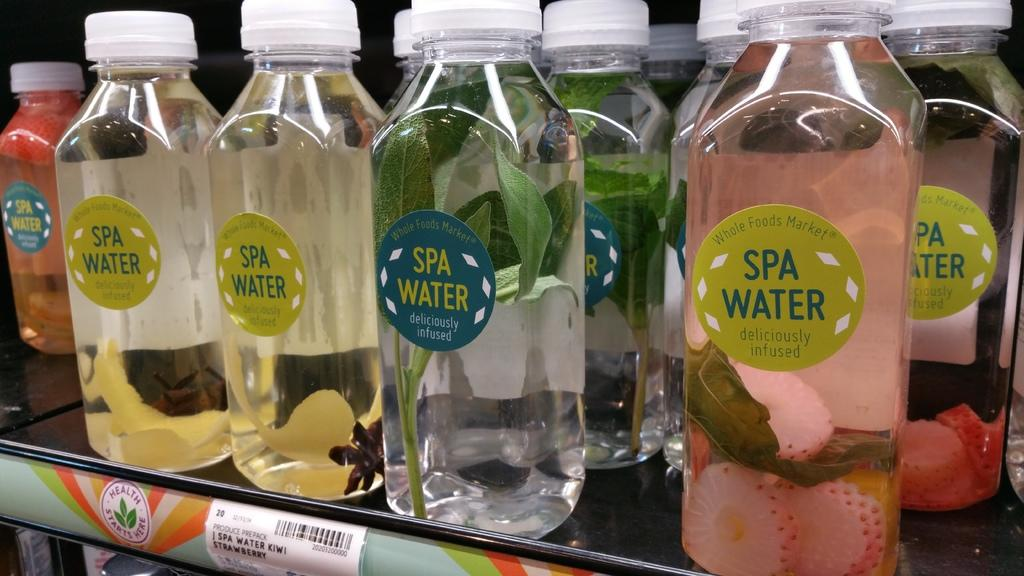<image>
Relay a brief, clear account of the picture shown. A bunch of different flavors of Spa Water on a shelve in a store. 